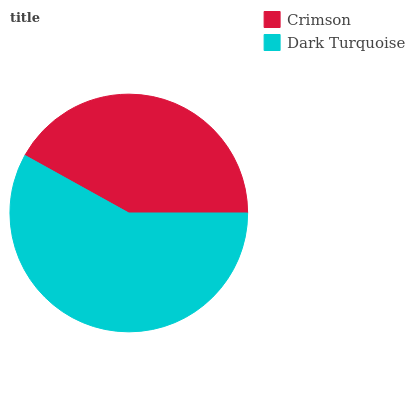Is Crimson the minimum?
Answer yes or no. Yes. Is Dark Turquoise the maximum?
Answer yes or no. Yes. Is Dark Turquoise the minimum?
Answer yes or no. No. Is Dark Turquoise greater than Crimson?
Answer yes or no. Yes. Is Crimson less than Dark Turquoise?
Answer yes or no. Yes. Is Crimson greater than Dark Turquoise?
Answer yes or no. No. Is Dark Turquoise less than Crimson?
Answer yes or no. No. Is Dark Turquoise the high median?
Answer yes or no. Yes. Is Crimson the low median?
Answer yes or no. Yes. Is Crimson the high median?
Answer yes or no. No. Is Dark Turquoise the low median?
Answer yes or no. No. 